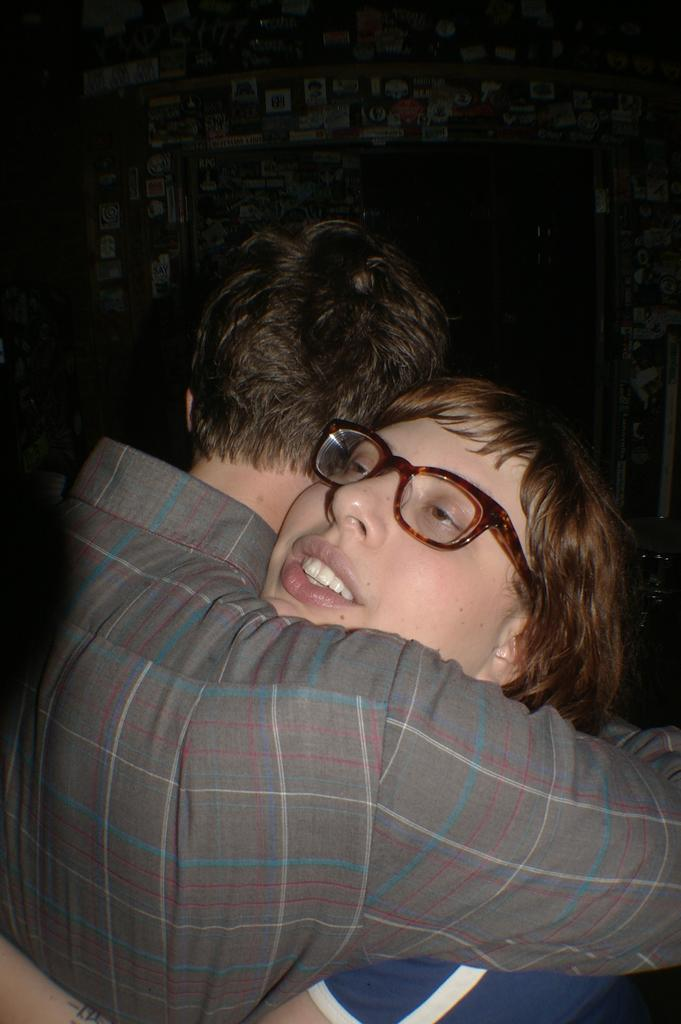How many people are in the image? There are two persons in the image. What are the two persons doing in the image? The two persons are standing and hugging. What type of magic is being performed by the two persons in the image? There is no magic being performed in the image; the two persons are simply standing and hugging. 